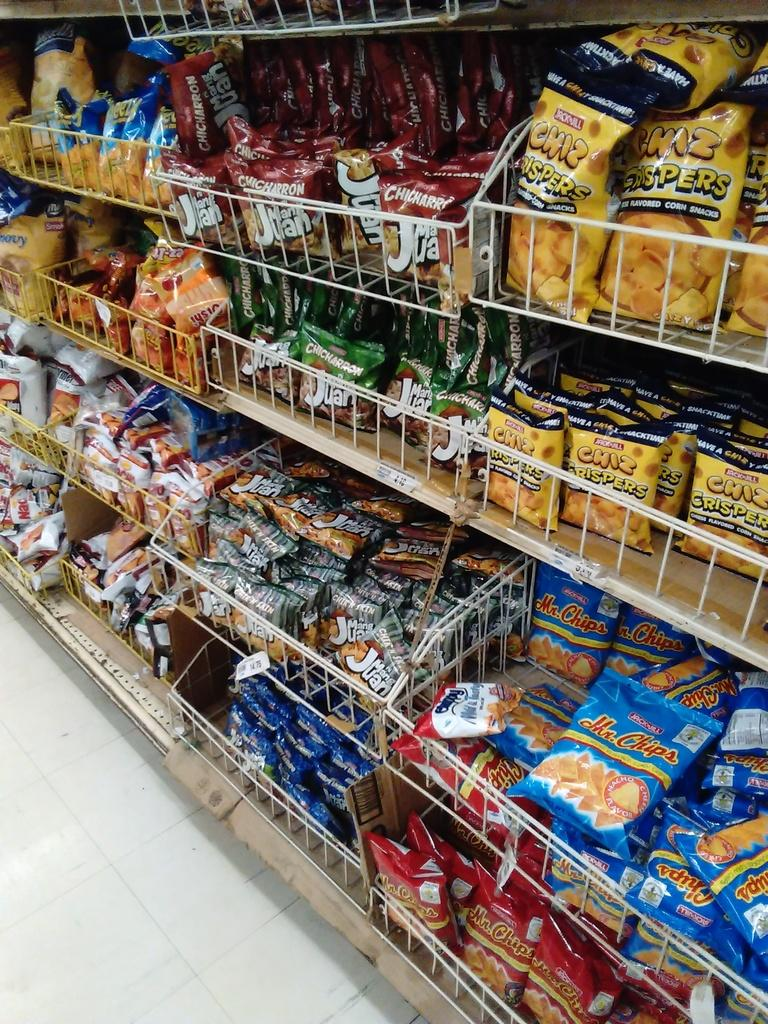<image>
Render a clear and concise summary of the photo. Blue bags of Mr. Chips chips are on a store shelf. 